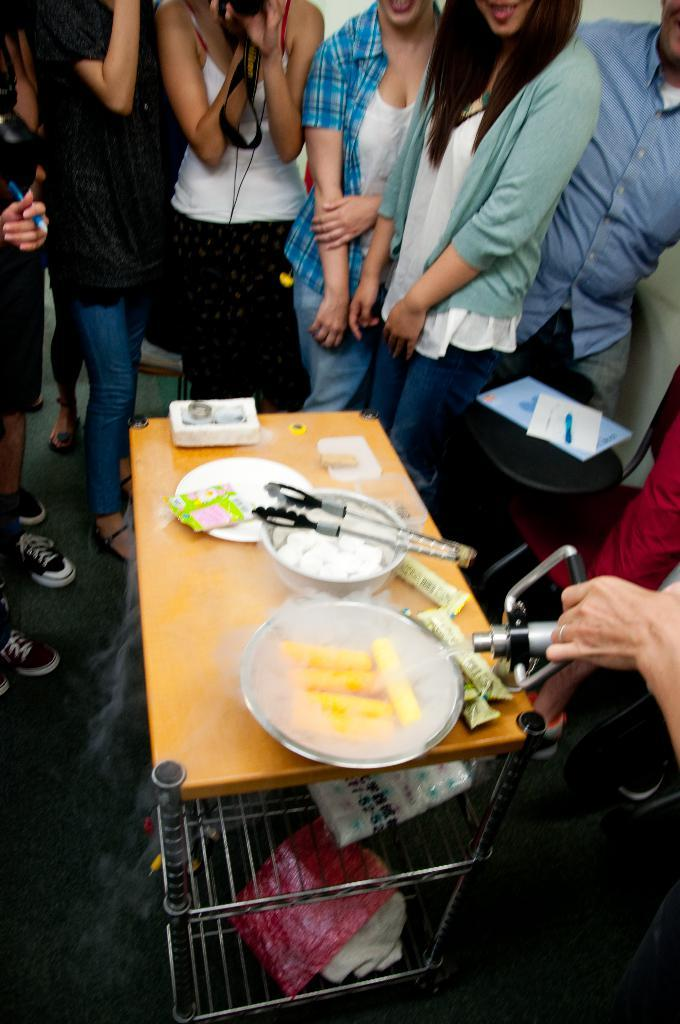What are the people in the image doing? The persons standing on the floor are likely interacting with the table and its contents. What is the primary piece of furniture in the image? There is a table in the image. What is on the table? There is a bowl and a plate on the table, both of which contain food. What is the chance of finding a pan in the image? There is no pan present in the image. What fictional character is depicted on the plate? The plate does not depict any fictional characters; it contains food. 